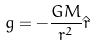Convert formula to latex. <formula><loc_0><loc_0><loc_500><loc_500>g = - { \frac { G M } { r ^ { 2 } } } \hat { r }</formula> 